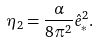Convert formula to latex. <formula><loc_0><loc_0><loc_500><loc_500>\eta _ { 2 } = \frac { \alpha } { 8 \pi ^ { 2 } } \hat { e } ^ { 2 } _ { * } .</formula> 